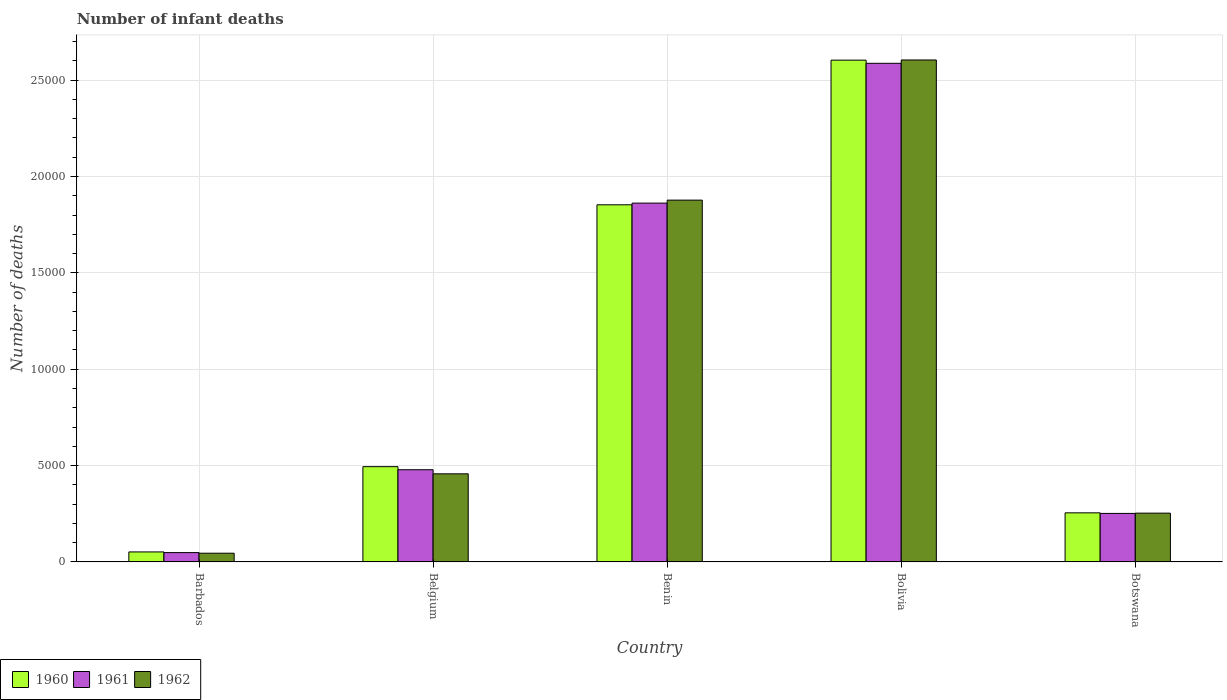How many groups of bars are there?
Your answer should be compact. 5. Are the number of bars on each tick of the X-axis equal?
Keep it short and to the point. Yes. How many bars are there on the 1st tick from the left?
Provide a short and direct response. 3. What is the label of the 1st group of bars from the left?
Your response must be concise. Barbados. In how many cases, is the number of bars for a given country not equal to the number of legend labels?
Offer a terse response. 0. What is the number of infant deaths in 1961 in Botswana?
Provide a short and direct response. 2516. Across all countries, what is the maximum number of infant deaths in 1961?
Keep it short and to the point. 2.59e+04. Across all countries, what is the minimum number of infant deaths in 1962?
Your answer should be very brief. 451. In which country was the number of infant deaths in 1962 maximum?
Provide a succinct answer. Bolivia. In which country was the number of infant deaths in 1961 minimum?
Your answer should be compact. Barbados. What is the total number of infant deaths in 1961 in the graph?
Ensure brevity in your answer.  5.23e+04. What is the difference between the number of infant deaths in 1961 in Benin and that in Bolivia?
Give a very brief answer. -7255. What is the difference between the number of infant deaths in 1962 in Botswana and the number of infant deaths in 1961 in Benin?
Your answer should be very brief. -1.61e+04. What is the average number of infant deaths in 1962 per country?
Offer a very short reply. 1.05e+04. What is the difference between the number of infant deaths of/in 1962 and number of infant deaths of/in 1960 in Benin?
Make the answer very short. 242. In how many countries, is the number of infant deaths in 1960 greater than 4000?
Give a very brief answer. 3. What is the ratio of the number of infant deaths in 1962 in Barbados to that in Belgium?
Give a very brief answer. 0.1. Is the number of infant deaths in 1961 in Barbados less than that in Bolivia?
Your answer should be very brief. Yes. What is the difference between the highest and the second highest number of infant deaths in 1962?
Keep it short and to the point. -1.42e+04. What is the difference between the highest and the lowest number of infant deaths in 1962?
Make the answer very short. 2.56e+04. What does the 2nd bar from the right in Barbados represents?
Provide a short and direct response. 1961. How many bars are there?
Your answer should be compact. 15. How many countries are there in the graph?
Your response must be concise. 5. Are the values on the major ticks of Y-axis written in scientific E-notation?
Keep it short and to the point. No. Does the graph contain any zero values?
Offer a terse response. No. Does the graph contain grids?
Provide a succinct answer. Yes. What is the title of the graph?
Provide a short and direct response. Number of infant deaths. What is the label or title of the Y-axis?
Offer a terse response. Number of deaths. What is the Number of deaths in 1960 in Barbados?
Your answer should be very brief. 518. What is the Number of deaths of 1961 in Barbados?
Give a very brief answer. 483. What is the Number of deaths of 1962 in Barbados?
Offer a terse response. 451. What is the Number of deaths in 1960 in Belgium?
Provide a succinct answer. 4942. What is the Number of deaths of 1961 in Belgium?
Offer a very short reply. 4783. What is the Number of deaths in 1962 in Belgium?
Your answer should be compact. 4571. What is the Number of deaths of 1960 in Benin?
Ensure brevity in your answer.  1.85e+04. What is the Number of deaths in 1961 in Benin?
Keep it short and to the point. 1.86e+04. What is the Number of deaths of 1962 in Benin?
Your answer should be compact. 1.88e+04. What is the Number of deaths in 1960 in Bolivia?
Make the answer very short. 2.60e+04. What is the Number of deaths of 1961 in Bolivia?
Your response must be concise. 2.59e+04. What is the Number of deaths of 1962 in Bolivia?
Ensure brevity in your answer.  2.60e+04. What is the Number of deaths of 1960 in Botswana?
Your response must be concise. 2546. What is the Number of deaths in 1961 in Botswana?
Offer a very short reply. 2516. What is the Number of deaths of 1962 in Botswana?
Keep it short and to the point. 2530. Across all countries, what is the maximum Number of deaths of 1960?
Ensure brevity in your answer.  2.60e+04. Across all countries, what is the maximum Number of deaths in 1961?
Give a very brief answer. 2.59e+04. Across all countries, what is the maximum Number of deaths of 1962?
Offer a terse response. 2.60e+04. Across all countries, what is the minimum Number of deaths in 1960?
Keep it short and to the point. 518. Across all countries, what is the minimum Number of deaths in 1961?
Keep it short and to the point. 483. Across all countries, what is the minimum Number of deaths in 1962?
Provide a succinct answer. 451. What is the total Number of deaths in 1960 in the graph?
Your answer should be very brief. 5.26e+04. What is the total Number of deaths of 1961 in the graph?
Your answer should be very brief. 5.23e+04. What is the total Number of deaths in 1962 in the graph?
Offer a very short reply. 5.24e+04. What is the difference between the Number of deaths in 1960 in Barbados and that in Belgium?
Your answer should be very brief. -4424. What is the difference between the Number of deaths in 1961 in Barbados and that in Belgium?
Provide a short and direct response. -4300. What is the difference between the Number of deaths in 1962 in Barbados and that in Belgium?
Give a very brief answer. -4120. What is the difference between the Number of deaths of 1960 in Barbados and that in Benin?
Make the answer very short. -1.80e+04. What is the difference between the Number of deaths in 1961 in Barbados and that in Benin?
Offer a very short reply. -1.81e+04. What is the difference between the Number of deaths in 1962 in Barbados and that in Benin?
Keep it short and to the point. -1.83e+04. What is the difference between the Number of deaths of 1960 in Barbados and that in Bolivia?
Keep it short and to the point. -2.55e+04. What is the difference between the Number of deaths of 1961 in Barbados and that in Bolivia?
Provide a succinct answer. -2.54e+04. What is the difference between the Number of deaths in 1962 in Barbados and that in Bolivia?
Your answer should be compact. -2.56e+04. What is the difference between the Number of deaths of 1960 in Barbados and that in Botswana?
Give a very brief answer. -2028. What is the difference between the Number of deaths in 1961 in Barbados and that in Botswana?
Offer a very short reply. -2033. What is the difference between the Number of deaths in 1962 in Barbados and that in Botswana?
Your answer should be compact. -2079. What is the difference between the Number of deaths of 1960 in Belgium and that in Benin?
Give a very brief answer. -1.36e+04. What is the difference between the Number of deaths in 1961 in Belgium and that in Benin?
Give a very brief answer. -1.38e+04. What is the difference between the Number of deaths of 1962 in Belgium and that in Benin?
Provide a short and direct response. -1.42e+04. What is the difference between the Number of deaths of 1960 in Belgium and that in Bolivia?
Offer a very short reply. -2.11e+04. What is the difference between the Number of deaths of 1961 in Belgium and that in Bolivia?
Make the answer very short. -2.11e+04. What is the difference between the Number of deaths of 1962 in Belgium and that in Bolivia?
Provide a succinct answer. -2.15e+04. What is the difference between the Number of deaths in 1960 in Belgium and that in Botswana?
Your response must be concise. 2396. What is the difference between the Number of deaths in 1961 in Belgium and that in Botswana?
Offer a terse response. 2267. What is the difference between the Number of deaths of 1962 in Belgium and that in Botswana?
Your answer should be compact. 2041. What is the difference between the Number of deaths in 1960 in Benin and that in Bolivia?
Your answer should be compact. -7506. What is the difference between the Number of deaths of 1961 in Benin and that in Bolivia?
Provide a succinct answer. -7255. What is the difference between the Number of deaths of 1962 in Benin and that in Bolivia?
Make the answer very short. -7273. What is the difference between the Number of deaths in 1960 in Benin and that in Botswana?
Your answer should be compact. 1.60e+04. What is the difference between the Number of deaths in 1961 in Benin and that in Botswana?
Give a very brief answer. 1.61e+04. What is the difference between the Number of deaths in 1962 in Benin and that in Botswana?
Your answer should be compact. 1.62e+04. What is the difference between the Number of deaths of 1960 in Bolivia and that in Botswana?
Make the answer very short. 2.35e+04. What is the difference between the Number of deaths in 1961 in Bolivia and that in Botswana?
Your answer should be compact. 2.34e+04. What is the difference between the Number of deaths in 1962 in Bolivia and that in Botswana?
Your answer should be very brief. 2.35e+04. What is the difference between the Number of deaths of 1960 in Barbados and the Number of deaths of 1961 in Belgium?
Your response must be concise. -4265. What is the difference between the Number of deaths of 1960 in Barbados and the Number of deaths of 1962 in Belgium?
Your response must be concise. -4053. What is the difference between the Number of deaths of 1961 in Barbados and the Number of deaths of 1962 in Belgium?
Your answer should be very brief. -4088. What is the difference between the Number of deaths of 1960 in Barbados and the Number of deaths of 1961 in Benin?
Offer a terse response. -1.81e+04. What is the difference between the Number of deaths of 1960 in Barbados and the Number of deaths of 1962 in Benin?
Your answer should be compact. -1.83e+04. What is the difference between the Number of deaths of 1961 in Barbados and the Number of deaths of 1962 in Benin?
Provide a succinct answer. -1.83e+04. What is the difference between the Number of deaths of 1960 in Barbados and the Number of deaths of 1961 in Bolivia?
Your answer should be very brief. -2.54e+04. What is the difference between the Number of deaths in 1960 in Barbados and the Number of deaths in 1962 in Bolivia?
Keep it short and to the point. -2.55e+04. What is the difference between the Number of deaths of 1961 in Barbados and the Number of deaths of 1962 in Bolivia?
Keep it short and to the point. -2.56e+04. What is the difference between the Number of deaths of 1960 in Barbados and the Number of deaths of 1961 in Botswana?
Your answer should be very brief. -1998. What is the difference between the Number of deaths of 1960 in Barbados and the Number of deaths of 1962 in Botswana?
Give a very brief answer. -2012. What is the difference between the Number of deaths in 1961 in Barbados and the Number of deaths in 1962 in Botswana?
Ensure brevity in your answer.  -2047. What is the difference between the Number of deaths of 1960 in Belgium and the Number of deaths of 1961 in Benin?
Ensure brevity in your answer.  -1.37e+04. What is the difference between the Number of deaths of 1960 in Belgium and the Number of deaths of 1962 in Benin?
Offer a terse response. -1.38e+04. What is the difference between the Number of deaths in 1961 in Belgium and the Number of deaths in 1962 in Benin?
Offer a very short reply. -1.40e+04. What is the difference between the Number of deaths in 1960 in Belgium and the Number of deaths in 1961 in Bolivia?
Offer a very short reply. -2.09e+04. What is the difference between the Number of deaths of 1960 in Belgium and the Number of deaths of 1962 in Bolivia?
Keep it short and to the point. -2.11e+04. What is the difference between the Number of deaths of 1961 in Belgium and the Number of deaths of 1962 in Bolivia?
Ensure brevity in your answer.  -2.13e+04. What is the difference between the Number of deaths in 1960 in Belgium and the Number of deaths in 1961 in Botswana?
Your answer should be very brief. 2426. What is the difference between the Number of deaths in 1960 in Belgium and the Number of deaths in 1962 in Botswana?
Your answer should be compact. 2412. What is the difference between the Number of deaths of 1961 in Belgium and the Number of deaths of 1962 in Botswana?
Offer a very short reply. 2253. What is the difference between the Number of deaths of 1960 in Benin and the Number of deaths of 1961 in Bolivia?
Give a very brief answer. -7342. What is the difference between the Number of deaths of 1960 in Benin and the Number of deaths of 1962 in Bolivia?
Make the answer very short. -7515. What is the difference between the Number of deaths in 1961 in Benin and the Number of deaths in 1962 in Bolivia?
Provide a succinct answer. -7428. What is the difference between the Number of deaths of 1960 in Benin and the Number of deaths of 1961 in Botswana?
Provide a succinct answer. 1.60e+04. What is the difference between the Number of deaths of 1960 in Benin and the Number of deaths of 1962 in Botswana?
Ensure brevity in your answer.  1.60e+04. What is the difference between the Number of deaths of 1961 in Benin and the Number of deaths of 1962 in Botswana?
Offer a very short reply. 1.61e+04. What is the difference between the Number of deaths of 1960 in Bolivia and the Number of deaths of 1961 in Botswana?
Offer a terse response. 2.35e+04. What is the difference between the Number of deaths in 1960 in Bolivia and the Number of deaths in 1962 in Botswana?
Offer a very short reply. 2.35e+04. What is the difference between the Number of deaths in 1961 in Bolivia and the Number of deaths in 1962 in Botswana?
Keep it short and to the point. 2.33e+04. What is the average Number of deaths in 1960 per country?
Provide a succinct answer. 1.05e+04. What is the average Number of deaths of 1961 per country?
Provide a succinct answer. 1.05e+04. What is the average Number of deaths in 1962 per country?
Your answer should be very brief. 1.05e+04. What is the difference between the Number of deaths of 1960 and Number of deaths of 1961 in Barbados?
Your response must be concise. 35. What is the difference between the Number of deaths of 1960 and Number of deaths of 1962 in Barbados?
Your answer should be compact. 67. What is the difference between the Number of deaths of 1960 and Number of deaths of 1961 in Belgium?
Offer a very short reply. 159. What is the difference between the Number of deaths of 1960 and Number of deaths of 1962 in Belgium?
Give a very brief answer. 371. What is the difference between the Number of deaths in 1961 and Number of deaths in 1962 in Belgium?
Give a very brief answer. 212. What is the difference between the Number of deaths in 1960 and Number of deaths in 1961 in Benin?
Your response must be concise. -87. What is the difference between the Number of deaths in 1960 and Number of deaths in 1962 in Benin?
Give a very brief answer. -242. What is the difference between the Number of deaths in 1961 and Number of deaths in 1962 in Benin?
Provide a short and direct response. -155. What is the difference between the Number of deaths of 1960 and Number of deaths of 1961 in Bolivia?
Your answer should be very brief. 164. What is the difference between the Number of deaths in 1961 and Number of deaths in 1962 in Bolivia?
Ensure brevity in your answer.  -173. What is the difference between the Number of deaths in 1960 and Number of deaths in 1961 in Botswana?
Offer a very short reply. 30. What is the difference between the Number of deaths in 1961 and Number of deaths in 1962 in Botswana?
Provide a short and direct response. -14. What is the ratio of the Number of deaths in 1960 in Barbados to that in Belgium?
Offer a terse response. 0.1. What is the ratio of the Number of deaths in 1961 in Barbados to that in Belgium?
Ensure brevity in your answer.  0.1. What is the ratio of the Number of deaths in 1962 in Barbados to that in Belgium?
Your response must be concise. 0.1. What is the ratio of the Number of deaths in 1960 in Barbados to that in Benin?
Your response must be concise. 0.03. What is the ratio of the Number of deaths of 1961 in Barbados to that in Benin?
Provide a short and direct response. 0.03. What is the ratio of the Number of deaths in 1962 in Barbados to that in Benin?
Provide a succinct answer. 0.02. What is the ratio of the Number of deaths of 1960 in Barbados to that in Bolivia?
Offer a terse response. 0.02. What is the ratio of the Number of deaths of 1961 in Barbados to that in Bolivia?
Your answer should be very brief. 0.02. What is the ratio of the Number of deaths of 1962 in Barbados to that in Bolivia?
Offer a very short reply. 0.02. What is the ratio of the Number of deaths in 1960 in Barbados to that in Botswana?
Make the answer very short. 0.2. What is the ratio of the Number of deaths in 1961 in Barbados to that in Botswana?
Your answer should be compact. 0.19. What is the ratio of the Number of deaths of 1962 in Barbados to that in Botswana?
Provide a short and direct response. 0.18. What is the ratio of the Number of deaths of 1960 in Belgium to that in Benin?
Provide a succinct answer. 0.27. What is the ratio of the Number of deaths of 1961 in Belgium to that in Benin?
Make the answer very short. 0.26. What is the ratio of the Number of deaths of 1962 in Belgium to that in Benin?
Your response must be concise. 0.24. What is the ratio of the Number of deaths of 1960 in Belgium to that in Bolivia?
Offer a very short reply. 0.19. What is the ratio of the Number of deaths of 1961 in Belgium to that in Bolivia?
Make the answer very short. 0.18. What is the ratio of the Number of deaths of 1962 in Belgium to that in Bolivia?
Your response must be concise. 0.18. What is the ratio of the Number of deaths of 1960 in Belgium to that in Botswana?
Your response must be concise. 1.94. What is the ratio of the Number of deaths in 1961 in Belgium to that in Botswana?
Keep it short and to the point. 1.9. What is the ratio of the Number of deaths of 1962 in Belgium to that in Botswana?
Offer a terse response. 1.81. What is the ratio of the Number of deaths of 1960 in Benin to that in Bolivia?
Ensure brevity in your answer.  0.71. What is the ratio of the Number of deaths in 1961 in Benin to that in Bolivia?
Provide a short and direct response. 0.72. What is the ratio of the Number of deaths in 1962 in Benin to that in Bolivia?
Your answer should be compact. 0.72. What is the ratio of the Number of deaths of 1960 in Benin to that in Botswana?
Keep it short and to the point. 7.28. What is the ratio of the Number of deaths in 1961 in Benin to that in Botswana?
Your answer should be compact. 7.4. What is the ratio of the Number of deaths in 1962 in Benin to that in Botswana?
Offer a terse response. 7.42. What is the ratio of the Number of deaths in 1960 in Bolivia to that in Botswana?
Your response must be concise. 10.23. What is the ratio of the Number of deaths of 1961 in Bolivia to that in Botswana?
Offer a very short reply. 10.28. What is the ratio of the Number of deaths in 1962 in Bolivia to that in Botswana?
Your response must be concise. 10.29. What is the difference between the highest and the second highest Number of deaths in 1960?
Your answer should be compact. 7506. What is the difference between the highest and the second highest Number of deaths in 1961?
Your answer should be very brief. 7255. What is the difference between the highest and the second highest Number of deaths in 1962?
Provide a succinct answer. 7273. What is the difference between the highest and the lowest Number of deaths in 1960?
Offer a terse response. 2.55e+04. What is the difference between the highest and the lowest Number of deaths in 1961?
Provide a short and direct response. 2.54e+04. What is the difference between the highest and the lowest Number of deaths in 1962?
Your answer should be very brief. 2.56e+04. 